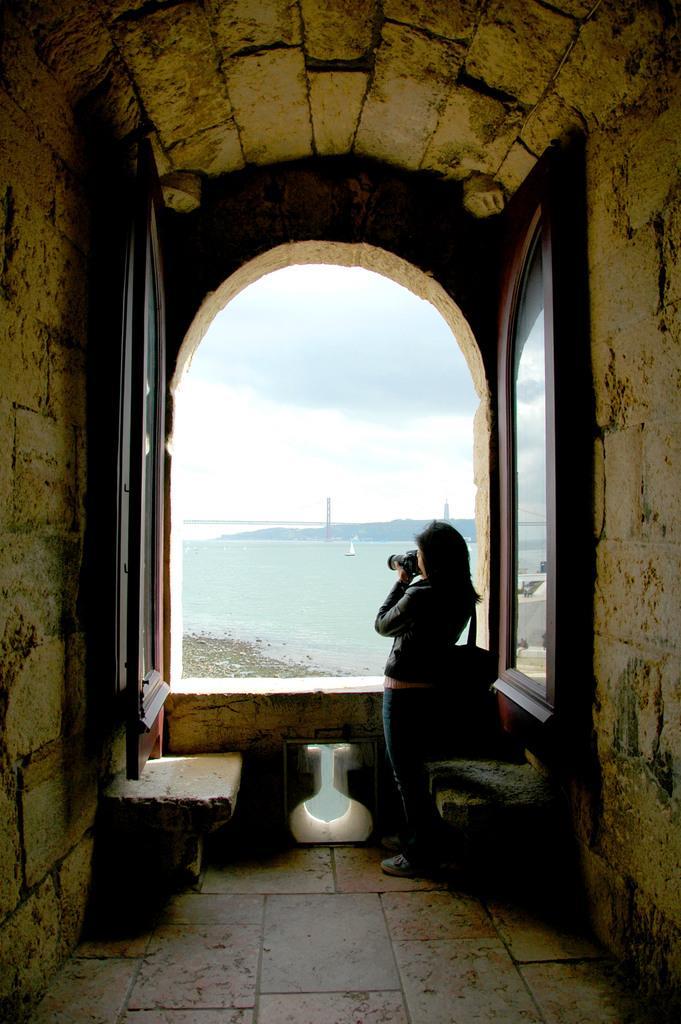Could you give a brief overview of what you see in this image? This is an inside view. On the right and left sides of the image I can see the walls. In the background there is a woman holding a camera in the hands and standing beside the window. To the window I can see two doors. In the outside I can see an ocean and sky. 